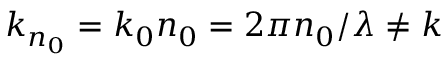Convert formula to latex. <formula><loc_0><loc_0><loc_500><loc_500>k _ { n _ { 0 } } = k _ { 0 } n _ { 0 } = 2 \pi n _ { 0 } / \lambda \neq k</formula> 